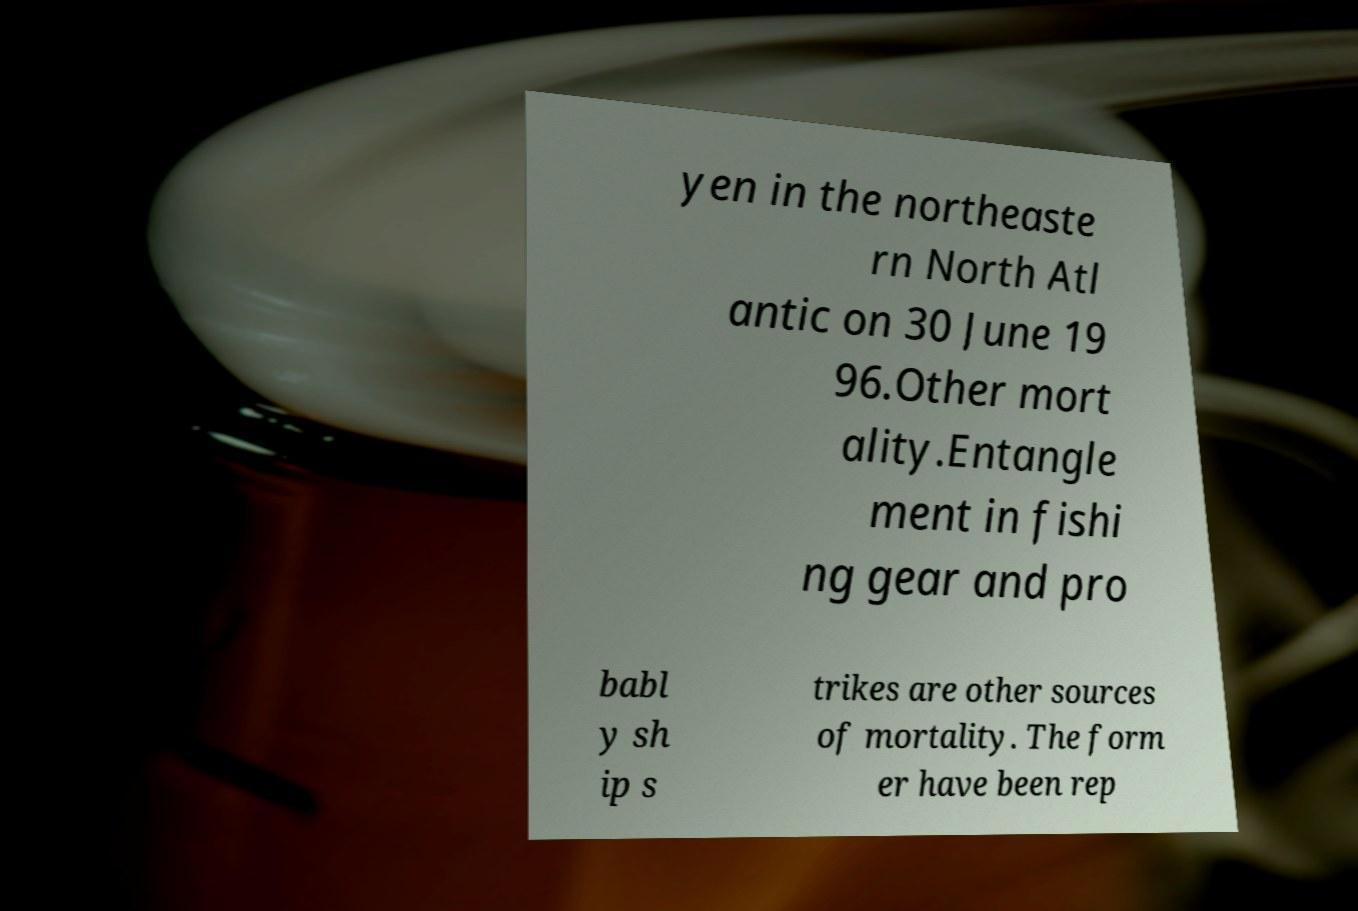Could you extract and type out the text from this image? yen in the northeaste rn North Atl antic on 30 June 19 96.Other mort ality.Entangle ment in fishi ng gear and pro babl y sh ip s trikes are other sources of mortality. The form er have been rep 